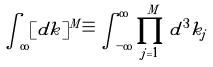Convert formula to latex. <formula><loc_0><loc_0><loc_500><loc_500>\int _ { \infty } [ d { k } ] ^ { M } \equiv \int _ { - \infty } ^ { \infty } \prod _ { j = 1 } ^ { M } d ^ { 3 } { k } _ { j }</formula> 